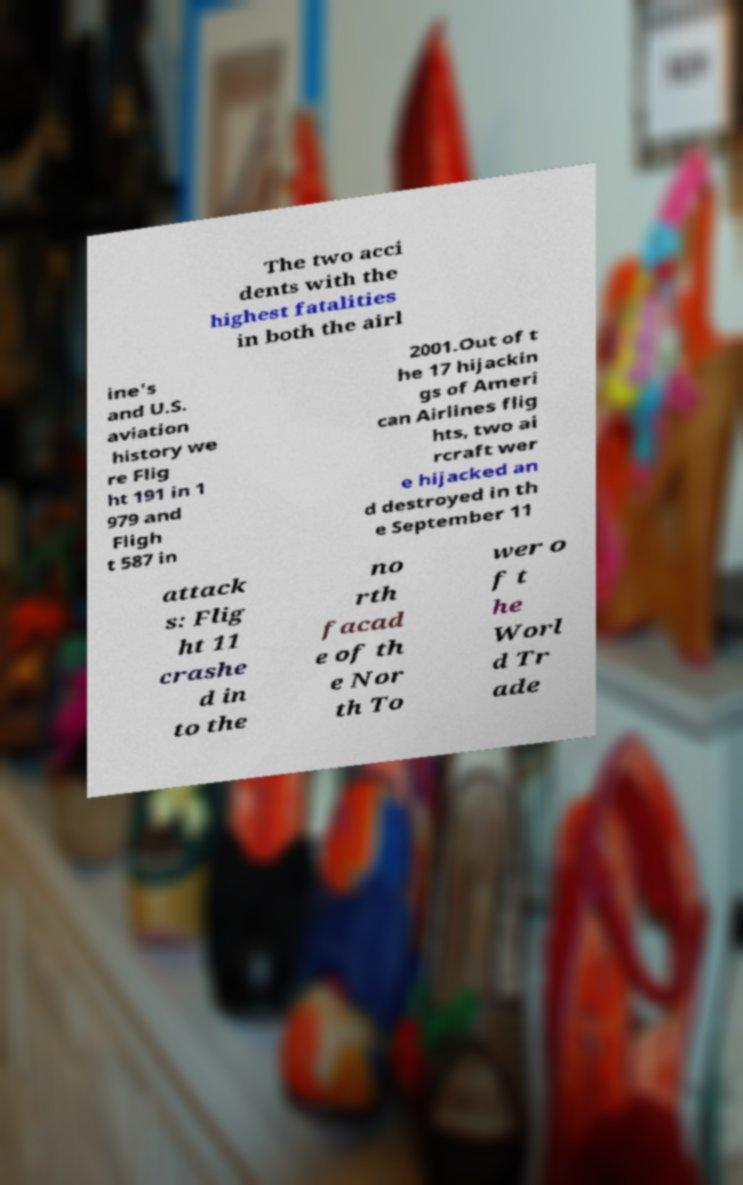Can you read and provide the text displayed in the image?This photo seems to have some interesting text. Can you extract and type it out for me? The two acci dents with the highest fatalities in both the airl ine's and U.S. aviation history we re Flig ht 191 in 1 979 and Fligh t 587 in 2001.Out of t he 17 hijackin gs of Ameri can Airlines flig hts, two ai rcraft wer e hijacked an d destroyed in th e September 11 attack s: Flig ht 11 crashe d in to the no rth facad e of th e Nor th To wer o f t he Worl d Tr ade 